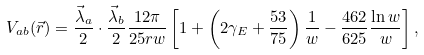Convert formula to latex. <formula><loc_0><loc_0><loc_500><loc_500>V _ { a b } ( \vec { r } ) = \frac { \vec { \lambda } _ { a } } { 2 } \cdot \frac { \vec { \lambda } _ { b } } { 2 } \frac { 1 2 \pi } { 2 5 r w } \left [ 1 + \left ( 2 \gamma _ { E } + \frac { 5 3 } { 7 5 } \right ) \frac { 1 } { w } - \frac { 4 6 2 } { 6 2 5 } \frac { \ln w } { w } \right ] ,</formula> 